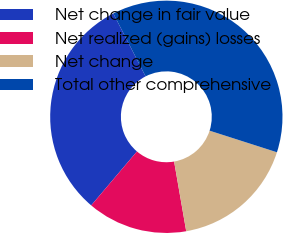Convert chart to OTSL. <chart><loc_0><loc_0><loc_500><loc_500><pie_chart><fcel>Net change in fair value<fcel>Net realized (gains) losses<fcel>Net change<fcel>Total other comprehensive<nl><fcel>31.26%<fcel>13.93%<fcel>17.32%<fcel>37.48%<nl></chart> 